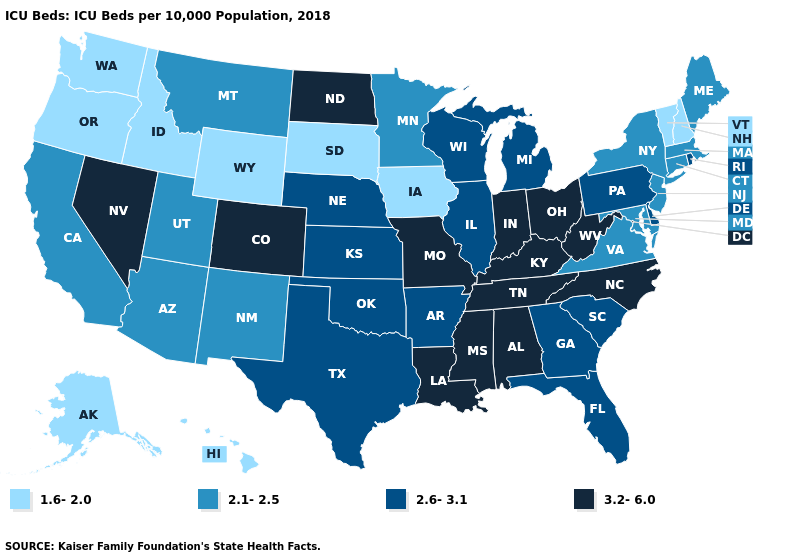Does the first symbol in the legend represent the smallest category?
Short answer required. Yes. Which states hav the highest value in the Northeast?
Quick response, please. Pennsylvania, Rhode Island. What is the value of Iowa?
Give a very brief answer. 1.6-2.0. What is the value of Vermont?
Concise answer only. 1.6-2.0. What is the lowest value in states that border Delaware?
Concise answer only. 2.1-2.5. How many symbols are there in the legend?
Be succinct. 4. Name the states that have a value in the range 2.6-3.1?
Keep it brief. Arkansas, Delaware, Florida, Georgia, Illinois, Kansas, Michigan, Nebraska, Oklahoma, Pennsylvania, Rhode Island, South Carolina, Texas, Wisconsin. What is the value of Illinois?
Give a very brief answer. 2.6-3.1. Does Arizona have the lowest value in the West?
Keep it brief. No. What is the highest value in the USA?
Short answer required. 3.2-6.0. Among the states that border Colorado , does Wyoming have the lowest value?
Quick response, please. Yes. Name the states that have a value in the range 2.1-2.5?
Answer briefly. Arizona, California, Connecticut, Maine, Maryland, Massachusetts, Minnesota, Montana, New Jersey, New Mexico, New York, Utah, Virginia. What is the lowest value in states that border Kentucky?
Quick response, please. 2.1-2.5. What is the lowest value in the USA?
Be succinct. 1.6-2.0. Name the states that have a value in the range 1.6-2.0?
Be succinct. Alaska, Hawaii, Idaho, Iowa, New Hampshire, Oregon, South Dakota, Vermont, Washington, Wyoming. 